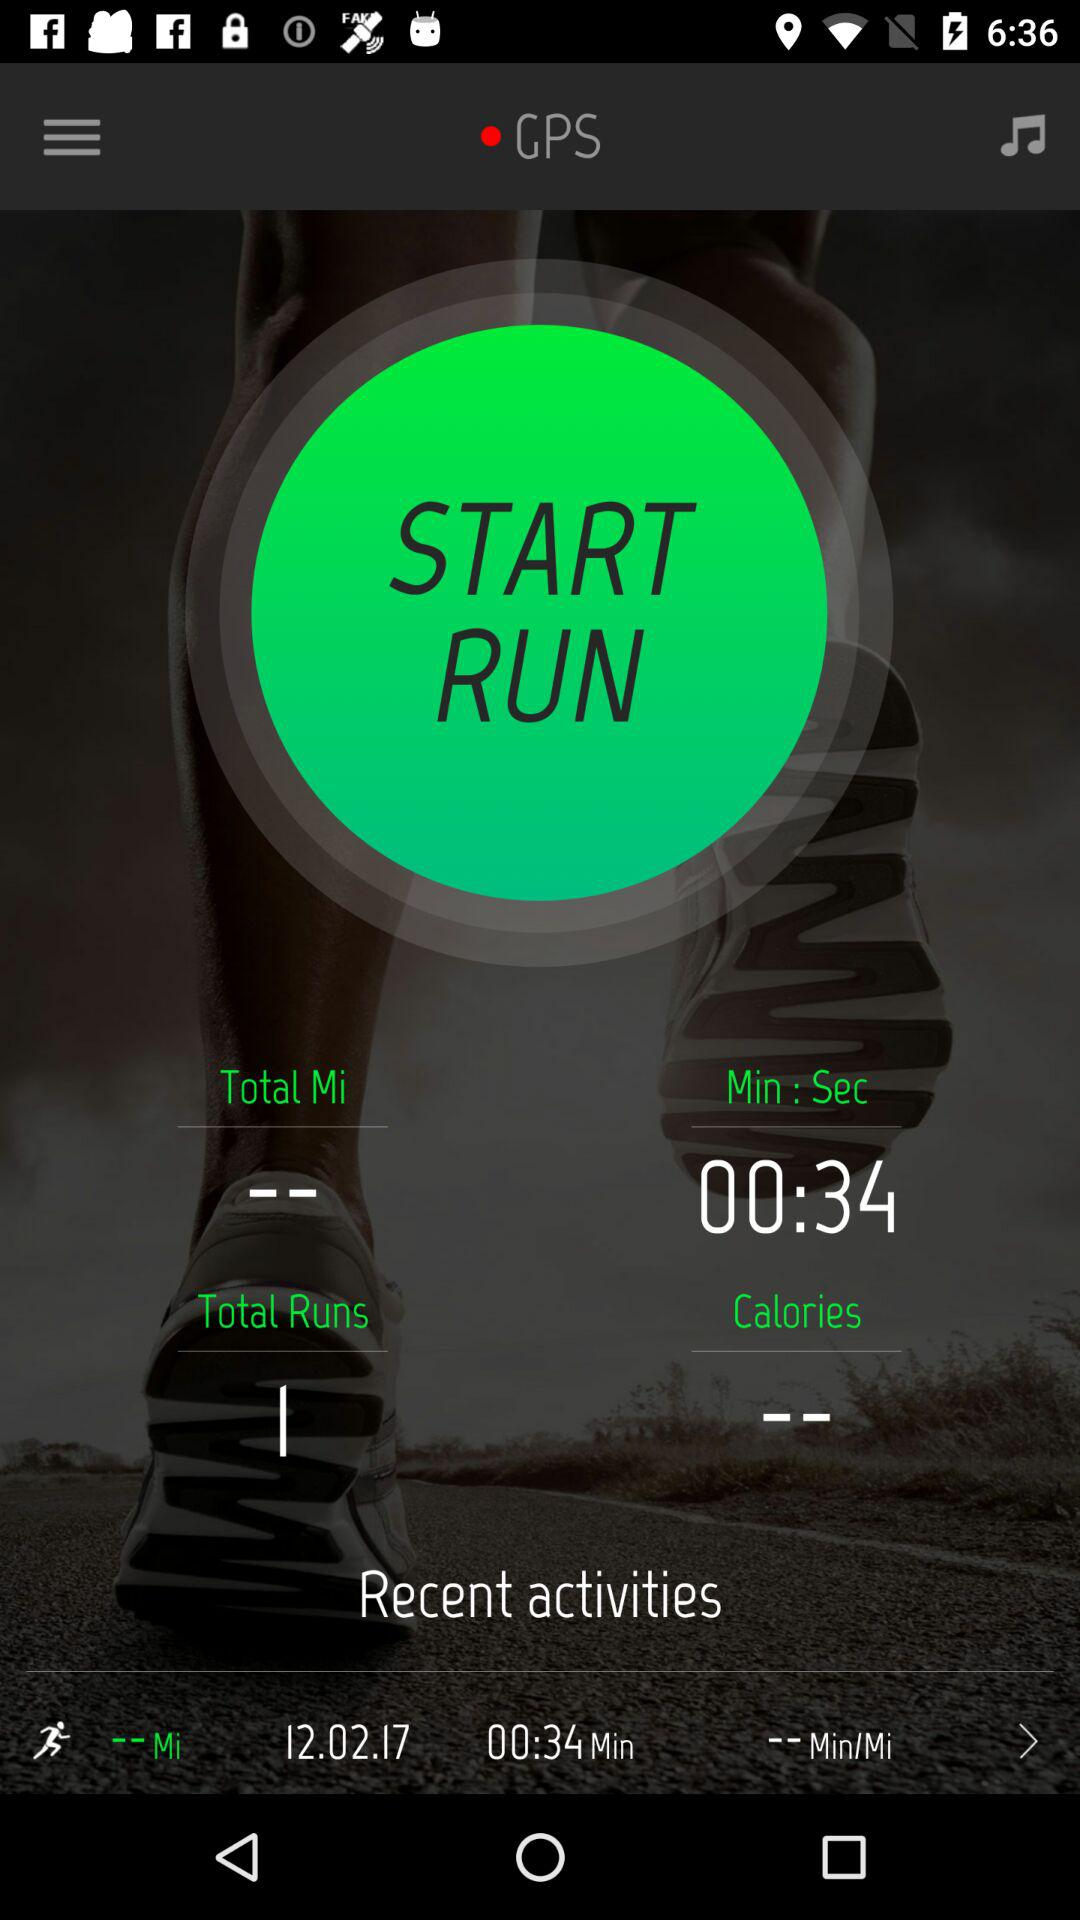What is the date of recent activities? The date of recent activities is December 2, 2017. 